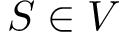Convert formula to latex. <formula><loc_0><loc_0><loc_500><loc_500>S \in V</formula> 